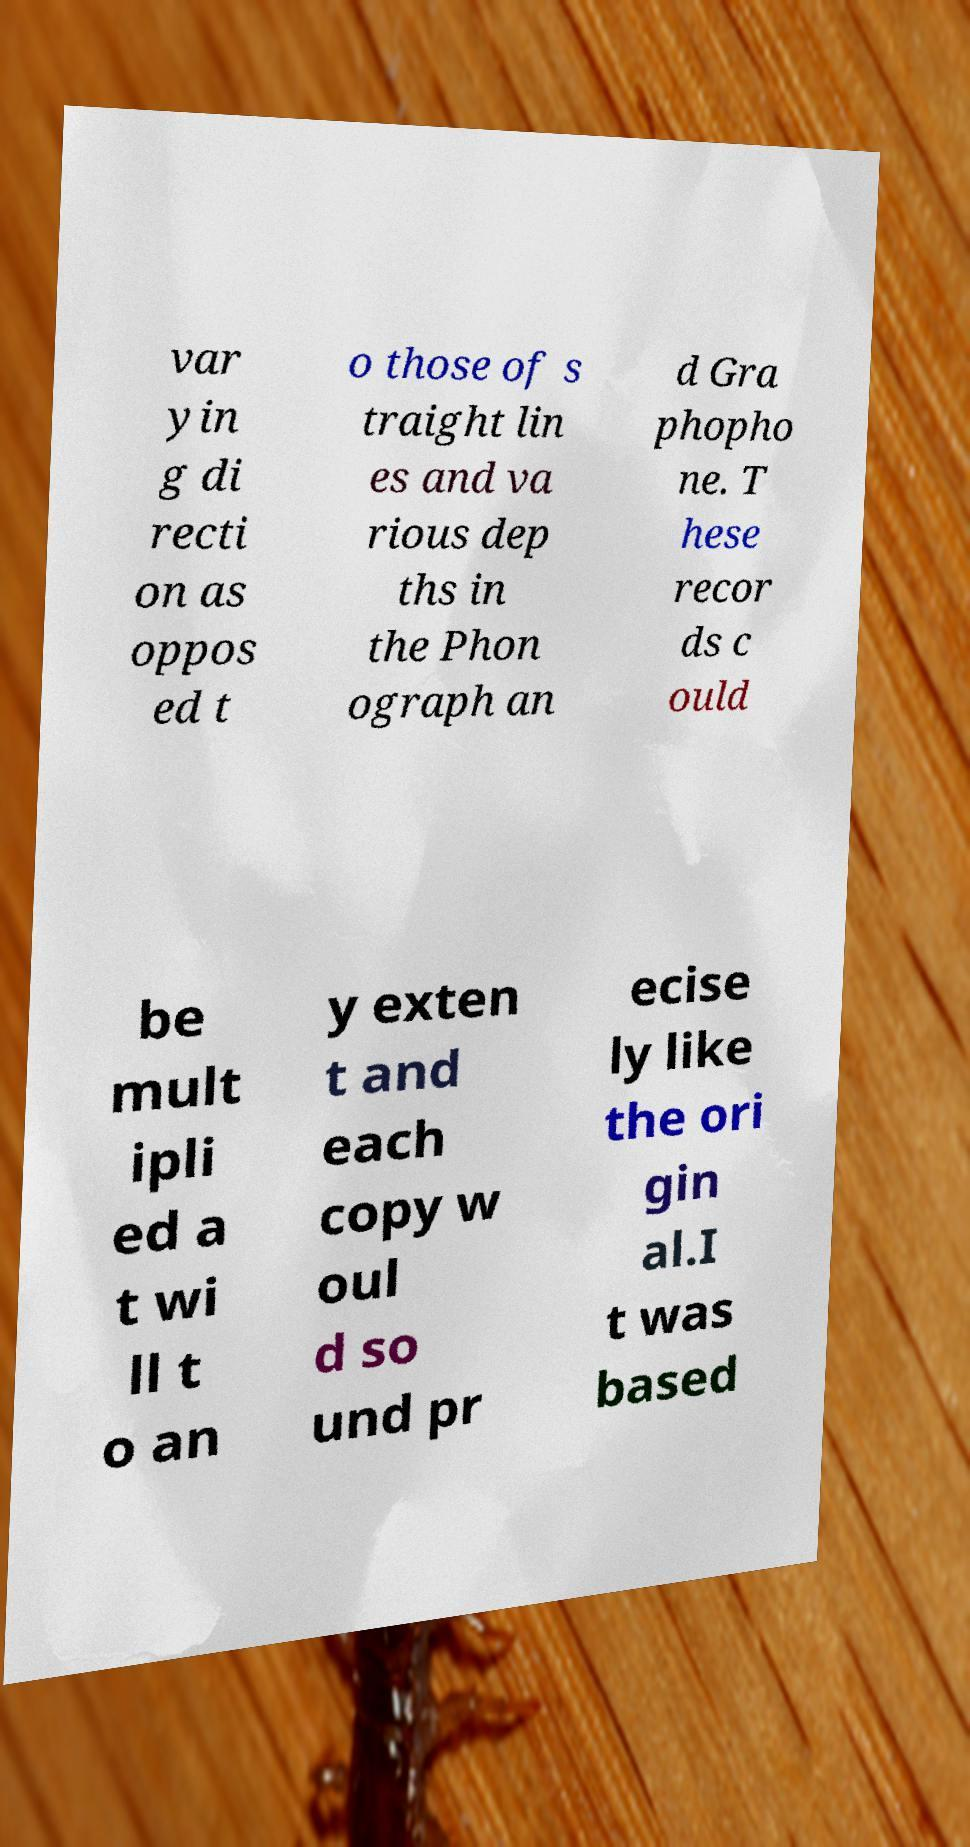What messages or text are displayed in this image? I need them in a readable, typed format. var yin g di recti on as oppos ed t o those of s traight lin es and va rious dep ths in the Phon ograph an d Gra phopho ne. T hese recor ds c ould be mult ipli ed a t wi ll t o an y exten t and each copy w oul d so und pr ecise ly like the ori gin al.I t was based 